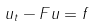<formula> <loc_0><loc_0><loc_500><loc_500>u _ { t } - F u = f</formula> 